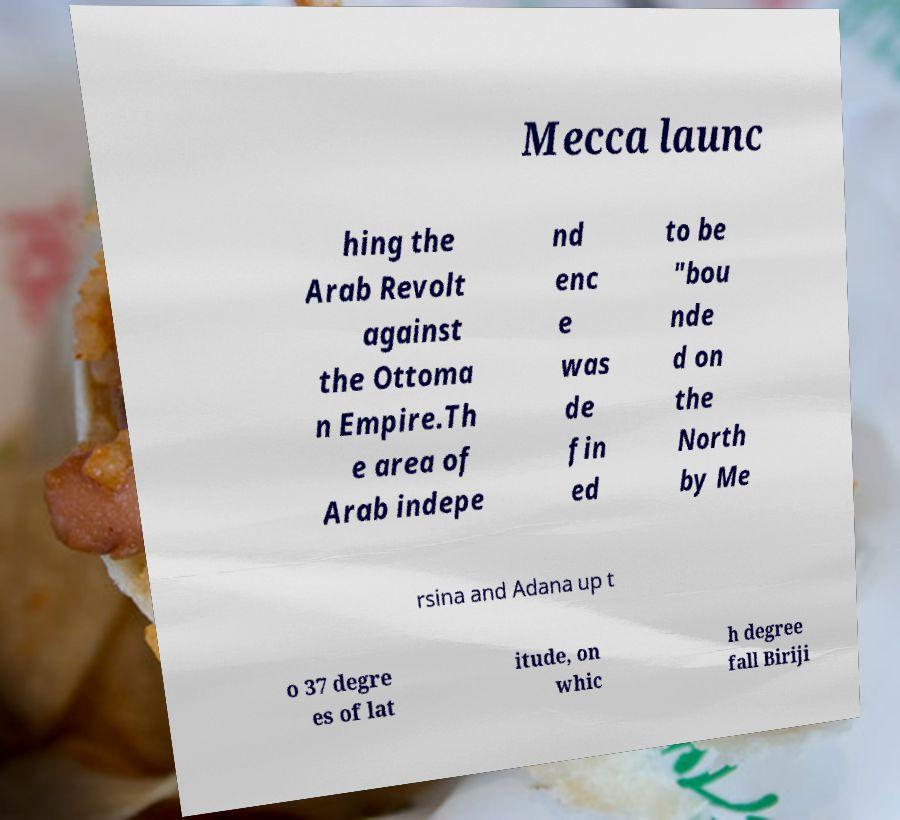Can you accurately transcribe the text from the provided image for me? Mecca launc hing the Arab Revolt against the Ottoma n Empire.Th e area of Arab indepe nd enc e was de fin ed to be "bou nde d on the North by Me rsina and Adana up t o 37 degre es of lat itude, on whic h degree fall Biriji 